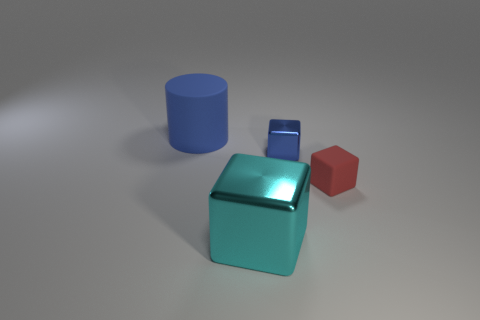Does the large object in front of the big cylinder have the same material as the large blue thing?
Provide a succinct answer. No. What number of objects are on the left side of the blue shiny block and on the right side of the blue cylinder?
Your response must be concise. 1. What is the color of the matte object in front of the blue thing to the right of the matte thing behind the tiny blue thing?
Offer a very short reply. Red. What number of other objects are there of the same shape as the tiny rubber thing?
Your response must be concise. 2. There is a blue thing to the right of the big cylinder; are there any rubber cylinders that are in front of it?
Keep it short and to the point. No. What number of metal objects are either tiny blocks or blue balls?
Provide a short and direct response. 1. There is a cube that is both behind the big cyan shiny thing and left of the small red thing; what material is it made of?
Keep it short and to the point. Metal. There is a big object that is to the left of the large object that is in front of the blue cylinder; is there a thing that is to the right of it?
Provide a short and direct response. Yes. Are there any other things that have the same material as the large blue thing?
Provide a succinct answer. Yes. There is a blue thing that is the same material as the red cube; what shape is it?
Offer a terse response. Cylinder. 